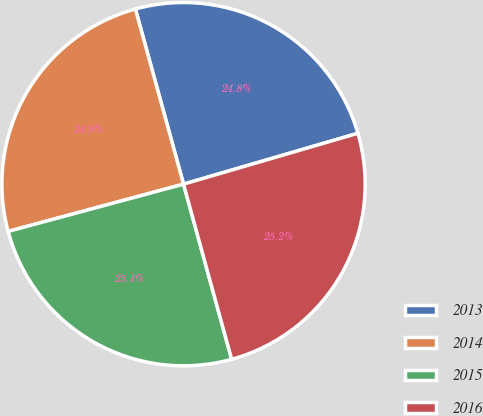Convert chart to OTSL. <chart><loc_0><loc_0><loc_500><loc_500><pie_chart><fcel>2013<fcel>2014<fcel>2015<fcel>2016<nl><fcel>24.75%<fcel>24.92%<fcel>25.08%<fcel>25.25%<nl></chart> 